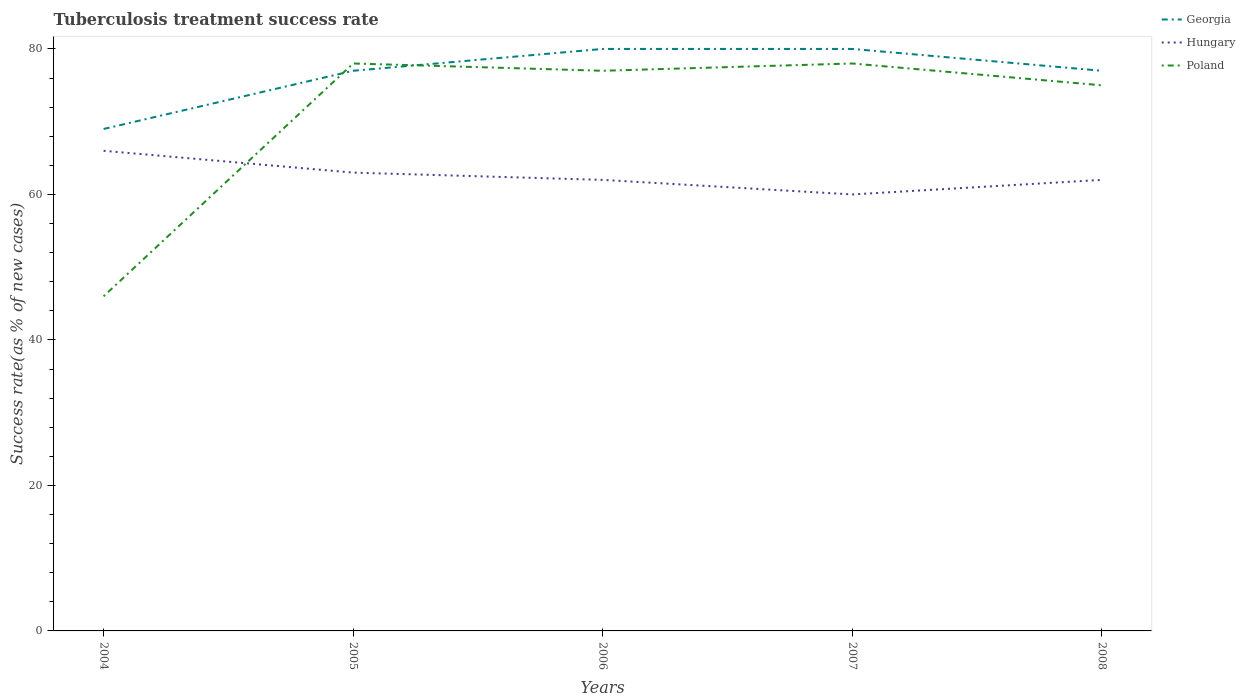How many different coloured lines are there?
Provide a succinct answer. 3. Is the number of lines equal to the number of legend labels?
Offer a terse response. Yes. In which year was the tuberculosis treatment success rate in Hungary maximum?
Your response must be concise. 2007. What is the total tuberculosis treatment success rate in Poland in the graph?
Provide a succinct answer. -1. What is the difference between the highest and the lowest tuberculosis treatment success rate in Georgia?
Provide a short and direct response. 4. Is the tuberculosis treatment success rate in Hungary strictly greater than the tuberculosis treatment success rate in Poland over the years?
Keep it short and to the point. No. How many lines are there?
Keep it short and to the point. 3. What is the difference between two consecutive major ticks on the Y-axis?
Your response must be concise. 20. What is the title of the graph?
Offer a terse response. Tuberculosis treatment success rate. Does "Botswana" appear as one of the legend labels in the graph?
Offer a very short reply. No. What is the label or title of the Y-axis?
Your answer should be very brief. Success rate(as % of new cases). What is the Success rate(as % of new cases) of Georgia in 2004?
Your answer should be compact. 69. What is the Success rate(as % of new cases) in Hungary in 2004?
Give a very brief answer. 66. What is the Success rate(as % of new cases) in Poland in 2004?
Offer a terse response. 46. What is the Success rate(as % of new cases) of Georgia in 2005?
Provide a short and direct response. 77. What is the Success rate(as % of new cases) in Poland in 2005?
Your response must be concise. 78. What is the Success rate(as % of new cases) of Georgia in 2006?
Provide a succinct answer. 80. What is the Success rate(as % of new cases) in Hungary in 2006?
Keep it short and to the point. 62. What is the Success rate(as % of new cases) in Hungary in 2007?
Your answer should be very brief. 60. What is the Success rate(as % of new cases) of Poland in 2007?
Ensure brevity in your answer.  78. What is the Success rate(as % of new cases) of Georgia in 2008?
Provide a succinct answer. 77. Across all years, what is the maximum Success rate(as % of new cases) of Georgia?
Offer a terse response. 80. Across all years, what is the maximum Success rate(as % of new cases) of Hungary?
Offer a very short reply. 66. What is the total Success rate(as % of new cases) of Georgia in the graph?
Make the answer very short. 383. What is the total Success rate(as % of new cases) in Hungary in the graph?
Offer a very short reply. 313. What is the total Success rate(as % of new cases) in Poland in the graph?
Provide a short and direct response. 354. What is the difference between the Success rate(as % of new cases) of Poland in 2004 and that in 2005?
Give a very brief answer. -32. What is the difference between the Success rate(as % of new cases) of Georgia in 2004 and that in 2006?
Keep it short and to the point. -11. What is the difference between the Success rate(as % of new cases) of Hungary in 2004 and that in 2006?
Give a very brief answer. 4. What is the difference between the Success rate(as % of new cases) of Poland in 2004 and that in 2006?
Ensure brevity in your answer.  -31. What is the difference between the Success rate(as % of new cases) of Georgia in 2004 and that in 2007?
Offer a very short reply. -11. What is the difference between the Success rate(as % of new cases) of Poland in 2004 and that in 2007?
Your response must be concise. -32. What is the difference between the Success rate(as % of new cases) of Georgia in 2005 and that in 2006?
Offer a terse response. -3. What is the difference between the Success rate(as % of new cases) of Poland in 2005 and that in 2006?
Make the answer very short. 1. What is the difference between the Success rate(as % of new cases) in Georgia in 2005 and that in 2008?
Your answer should be compact. 0. What is the difference between the Success rate(as % of new cases) of Hungary in 2005 and that in 2008?
Ensure brevity in your answer.  1. What is the difference between the Success rate(as % of new cases) of Poland in 2005 and that in 2008?
Your answer should be very brief. 3. What is the difference between the Success rate(as % of new cases) of Poland in 2006 and that in 2007?
Offer a very short reply. -1. What is the difference between the Success rate(as % of new cases) of Georgia in 2006 and that in 2008?
Offer a terse response. 3. What is the difference between the Success rate(as % of new cases) of Poland in 2006 and that in 2008?
Provide a short and direct response. 2. What is the difference between the Success rate(as % of new cases) in Georgia in 2007 and that in 2008?
Ensure brevity in your answer.  3. What is the difference between the Success rate(as % of new cases) of Poland in 2007 and that in 2008?
Provide a succinct answer. 3. What is the difference between the Success rate(as % of new cases) of Georgia in 2004 and the Success rate(as % of new cases) of Poland in 2005?
Give a very brief answer. -9. What is the difference between the Success rate(as % of new cases) of Georgia in 2004 and the Success rate(as % of new cases) of Hungary in 2006?
Give a very brief answer. 7. What is the difference between the Success rate(as % of new cases) in Hungary in 2004 and the Success rate(as % of new cases) in Poland in 2006?
Give a very brief answer. -11. What is the difference between the Success rate(as % of new cases) of Georgia in 2004 and the Success rate(as % of new cases) of Hungary in 2007?
Provide a succinct answer. 9. What is the difference between the Success rate(as % of new cases) in Hungary in 2005 and the Success rate(as % of new cases) in Poland in 2006?
Provide a short and direct response. -14. What is the difference between the Success rate(as % of new cases) of Georgia in 2005 and the Success rate(as % of new cases) of Poland in 2007?
Keep it short and to the point. -1. What is the difference between the Success rate(as % of new cases) in Hungary in 2005 and the Success rate(as % of new cases) in Poland in 2007?
Provide a succinct answer. -15. What is the difference between the Success rate(as % of new cases) of Georgia in 2005 and the Success rate(as % of new cases) of Poland in 2008?
Ensure brevity in your answer.  2. What is the difference between the Success rate(as % of new cases) in Hungary in 2005 and the Success rate(as % of new cases) in Poland in 2008?
Provide a short and direct response. -12. What is the difference between the Success rate(as % of new cases) of Georgia in 2006 and the Success rate(as % of new cases) of Poland in 2007?
Offer a very short reply. 2. What is the difference between the Success rate(as % of new cases) in Hungary in 2006 and the Success rate(as % of new cases) in Poland in 2007?
Ensure brevity in your answer.  -16. What is the difference between the Success rate(as % of new cases) of Georgia in 2006 and the Success rate(as % of new cases) of Hungary in 2008?
Keep it short and to the point. 18. What is the difference between the Success rate(as % of new cases) of Georgia in 2006 and the Success rate(as % of new cases) of Poland in 2008?
Keep it short and to the point. 5. What is the difference between the Success rate(as % of new cases) of Hungary in 2007 and the Success rate(as % of new cases) of Poland in 2008?
Ensure brevity in your answer.  -15. What is the average Success rate(as % of new cases) of Georgia per year?
Provide a short and direct response. 76.6. What is the average Success rate(as % of new cases) in Hungary per year?
Your answer should be very brief. 62.6. What is the average Success rate(as % of new cases) of Poland per year?
Offer a terse response. 70.8. In the year 2005, what is the difference between the Success rate(as % of new cases) in Georgia and Success rate(as % of new cases) in Poland?
Ensure brevity in your answer.  -1. In the year 2006, what is the difference between the Success rate(as % of new cases) in Georgia and Success rate(as % of new cases) in Hungary?
Give a very brief answer. 18. In the year 2006, what is the difference between the Success rate(as % of new cases) in Hungary and Success rate(as % of new cases) in Poland?
Offer a terse response. -15. In the year 2007, what is the difference between the Success rate(as % of new cases) of Georgia and Success rate(as % of new cases) of Hungary?
Ensure brevity in your answer.  20. In the year 2008, what is the difference between the Success rate(as % of new cases) in Georgia and Success rate(as % of new cases) in Poland?
Give a very brief answer. 2. What is the ratio of the Success rate(as % of new cases) in Georgia in 2004 to that in 2005?
Your response must be concise. 0.9. What is the ratio of the Success rate(as % of new cases) in Hungary in 2004 to that in 2005?
Ensure brevity in your answer.  1.05. What is the ratio of the Success rate(as % of new cases) in Poland in 2004 to that in 2005?
Your answer should be very brief. 0.59. What is the ratio of the Success rate(as % of new cases) of Georgia in 2004 to that in 2006?
Ensure brevity in your answer.  0.86. What is the ratio of the Success rate(as % of new cases) in Hungary in 2004 to that in 2006?
Your answer should be very brief. 1.06. What is the ratio of the Success rate(as % of new cases) of Poland in 2004 to that in 2006?
Offer a very short reply. 0.6. What is the ratio of the Success rate(as % of new cases) in Georgia in 2004 to that in 2007?
Offer a very short reply. 0.86. What is the ratio of the Success rate(as % of new cases) of Hungary in 2004 to that in 2007?
Make the answer very short. 1.1. What is the ratio of the Success rate(as % of new cases) in Poland in 2004 to that in 2007?
Provide a short and direct response. 0.59. What is the ratio of the Success rate(as % of new cases) of Georgia in 2004 to that in 2008?
Your answer should be compact. 0.9. What is the ratio of the Success rate(as % of new cases) in Hungary in 2004 to that in 2008?
Make the answer very short. 1.06. What is the ratio of the Success rate(as % of new cases) of Poland in 2004 to that in 2008?
Offer a very short reply. 0.61. What is the ratio of the Success rate(as % of new cases) of Georgia in 2005 to that in 2006?
Offer a very short reply. 0.96. What is the ratio of the Success rate(as % of new cases) of Hungary in 2005 to that in 2006?
Offer a terse response. 1.02. What is the ratio of the Success rate(as % of new cases) in Poland in 2005 to that in 2006?
Keep it short and to the point. 1.01. What is the ratio of the Success rate(as % of new cases) in Georgia in 2005 to that in 2007?
Make the answer very short. 0.96. What is the ratio of the Success rate(as % of new cases) in Georgia in 2005 to that in 2008?
Make the answer very short. 1. What is the ratio of the Success rate(as % of new cases) of Hungary in 2005 to that in 2008?
Provide a succinct answer. 1.02. What is the ratio of the Success rate(as % of new cases) in Georgia in 2006 to that in 2007?
Ensure brevity in your answer.  1. What is the ratio of the Success rate(as % of new cases) in Poland in 2006 to that in 2007?
Offer a very short reply. 0.99. What is the ratio of the Success rate(as % of new cases) of Georgia in 2006 to that in 2008?
Keep it short and to the point. 1.04. What is the ratio of the Success rate(as % of new cases) in Poland in 2006 to that in 2008?
Your answer should be very brief. 1.03. What is the ratio of the Success rate(as % of new cases) in Georgia in 2007 to that in 2008?
Ensure brevity in your answer.  1.04. What is the ratio of the Success rate(as % of new cases) of Hungary in 2007 to that in 2008?
Your answer should be compact. 0.97. What is the ratio of the Success rate(as % of new cases) in Poland in 2007 to that in 2008?
Provide a short and direct response. 1.04. What is the difference between the highest and the second highest Success rate(as % of new cases) in Georgia?
Provide a short and direct response. 0. What is the difference between the highest and the lowest Success rate(as % of new cases) of Georgia?
Provide a succinct answer. 11. What is the difference between the highest and the lowest Success rate(as % of new cases) of Hungary?
Offer a terse response. 6. 